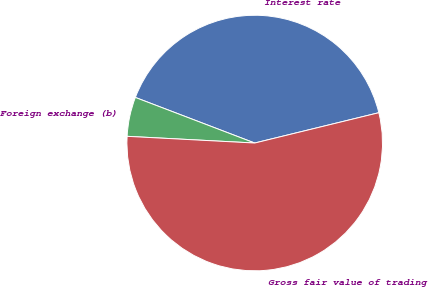Convert chart to OTSL. <chart><loc_0><loc_0><loc_500><loc_500><pie_chart><fcel>Interest rate<fcel>Foreign exchange (b)<fcel>Gross fair value of trading<nl><fcel>40.38%<fcel>4.97%<fcel>54.65%<nl></chart> 